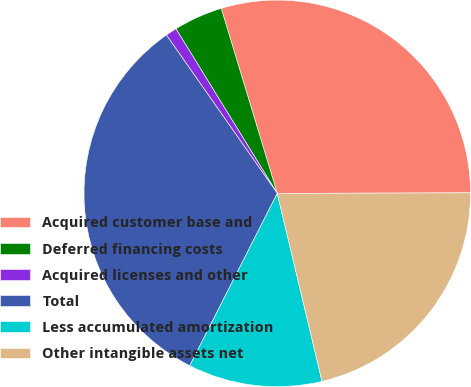Convert chart to OTSL. <chart><loc_0><loc_0><loc_500><loc_500><pie_chart><fcel>Acquired customer base and<fcel>Deferred financing costs<fcel>Acquired licenses and other<fcel>Total<fcel>Less accumulated amortization<fcel>Other intangible assets net<nl><fcel>29.64%<fcel>4.1%<fcel>0.94%<fcel>32.8%<fcel>11.2%<fcel>21.32%<nl></chart> 